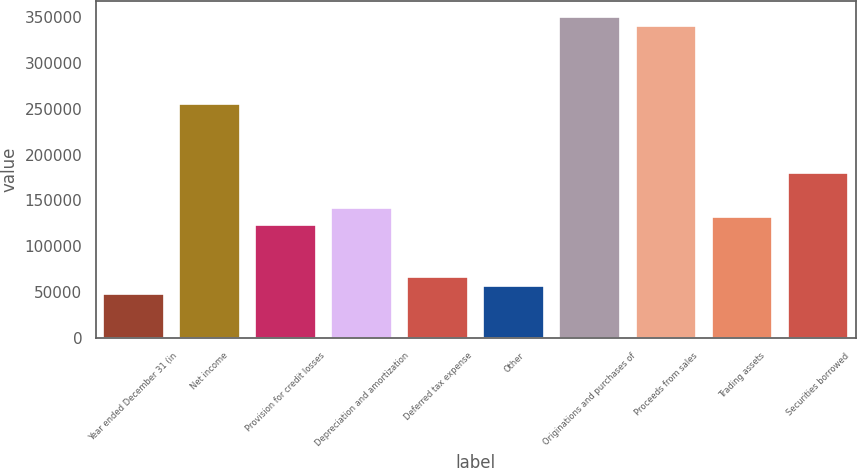<chart> <loc_0><loc_0><loc_500><loc_500><bar_chart><fcel>Year ended December 31 (in<fcel>Net income<fcel>Provision for credit losses<fcel>Depreciation and amortization<fcel>Deferred tax expense<fcel>Other<fcel>Originations and purchases of<fcel>Proceeds from sales<fcel>Trading assets<fcel>Securities borrowed<nl><fcel>47362<fcel>255332<fcel>122988<fcel>141894<fcel>66268.4<fcel>56815.2<fcel>349864<fcel>340411<fcel>132441<fcel>179707<nl></chart> 